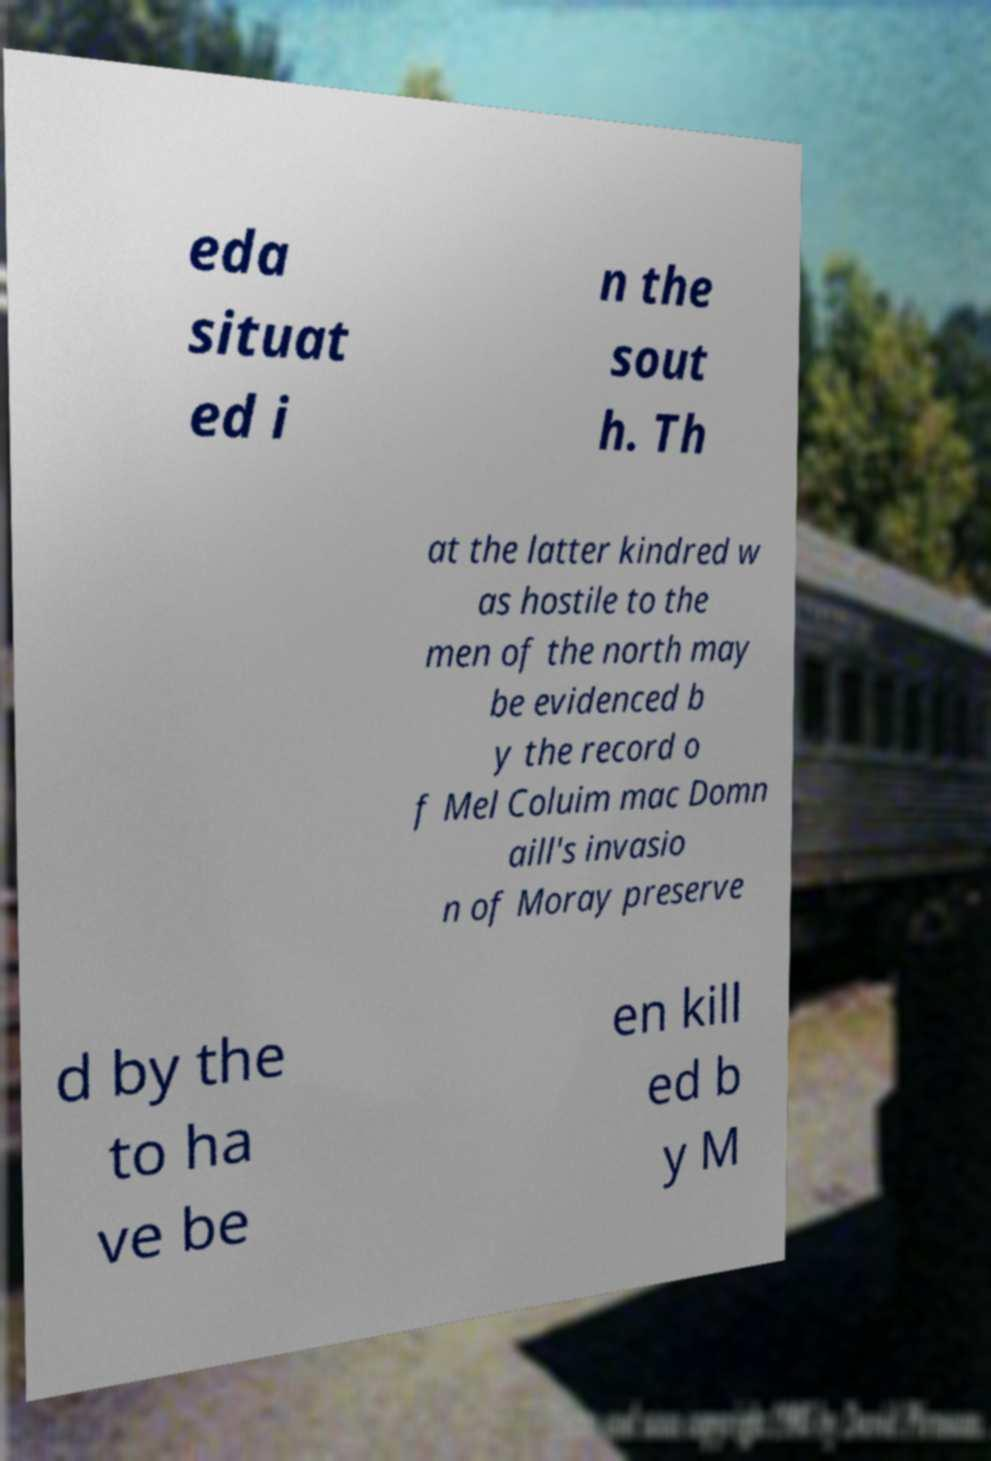For documentation purposes, I need the text within this image transcribed. Could you provide that? eda situat ed i n the sout h. Th at the latter kindred w as hostile to the men of the north may be evidenced b y the record o f Mel Coluim mac Domn aill's invasio n of Moray preserve d by the to ha ve be en kill ed b y M 